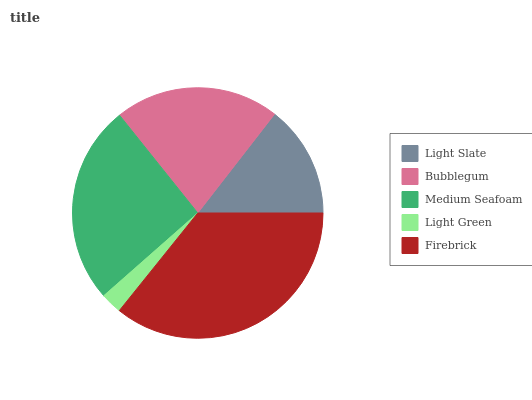Is Light Green the minimum?
Answer yes or no. Yes. Is Firebrick the maximum?
Answer yes or no. Yes. Is Bubblegum the minimum?
Answer yes or no. No. Is Bubblegum the maximum?
Answer yes or no. No. Is Bubblegum greater than Light Slate?
Answer yes or no. Yes. Is Light Slate less than Bubblegum?
Answer yes or no. Yes. Is Light Slate greater than Bubblegum?
Answer yes or no. No. Is Bubblegum less than Light Slate?
Answer yes or no. No. Is Bubblegum the high median?
Answer yes or no. Yes. Is Bubblegum the low median?
Answer yes or no. Yes. Is Medium Seafoam the high median?
Answer yes or no. No. Is Medium Seafoam the low median?
Answer yes or no. No. 